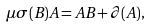Convert formula to latex. <formula><loc_0><loc_0><loc_500><loc_500>\mu \sigma ( B ) A = A B + \partial ( A ) ,</formula> 